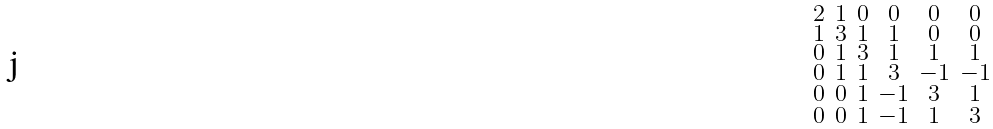<formula> <loc_0><loc_0><loc_500><loc_500>\begin{smallmatrix} 2 & 1 & 0 & 0 & 0 & 0 \\ 1 & 3 & 1 & 1 & 0 & 0 \\ 0 & 1 & 3 & 1 & 1 & 1 \\ 0 & 1 & 1 & 3 & - 1 & - 1 \\ 0 & 0 & 1 & - 1 & 3 & 1 \\ 0 & 0 & 1 & - 1 & 1 & 3 \end{smallmatrix}</formula> 